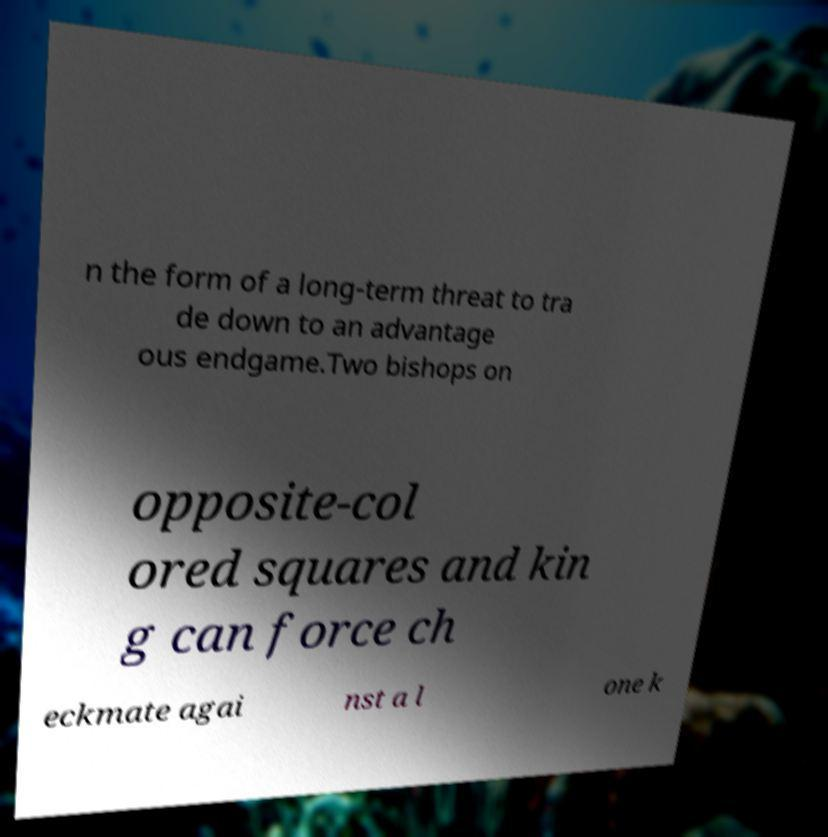Please identify and transcribe the text found in this image. n the form of a long-term threat to tra de down to an advantage ous endgame.Two bishops on opposite-col ored squares and kin g can force ch eckmate agai nst a l one k 